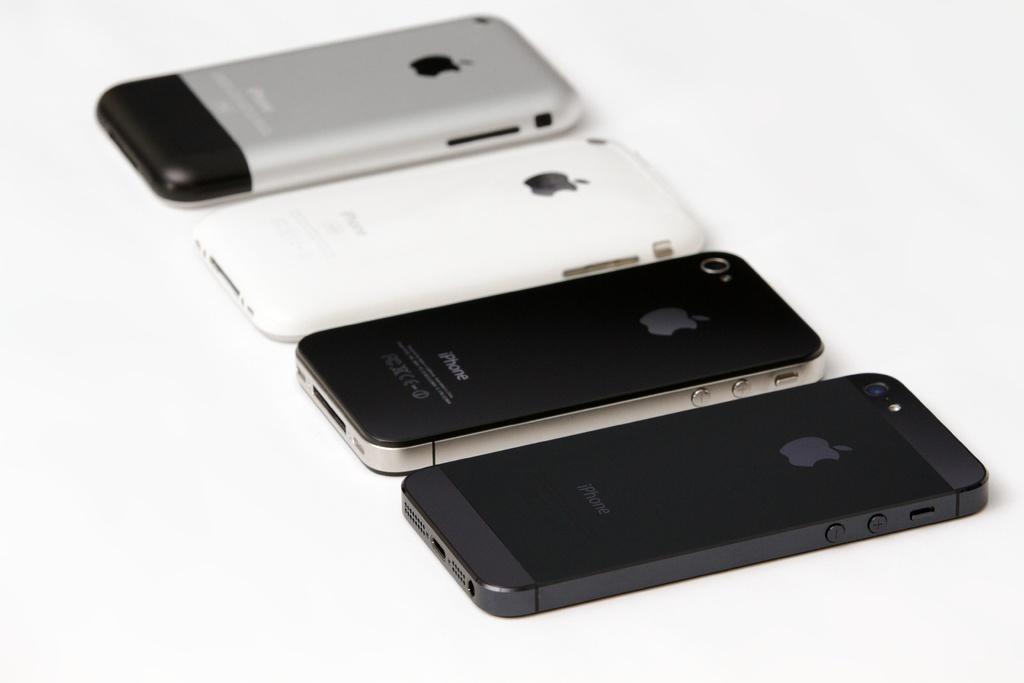Is this an apple iphone?
Offer a very short reply. Yes. What brand of phones are these?
Make the answer very short. Apple. 